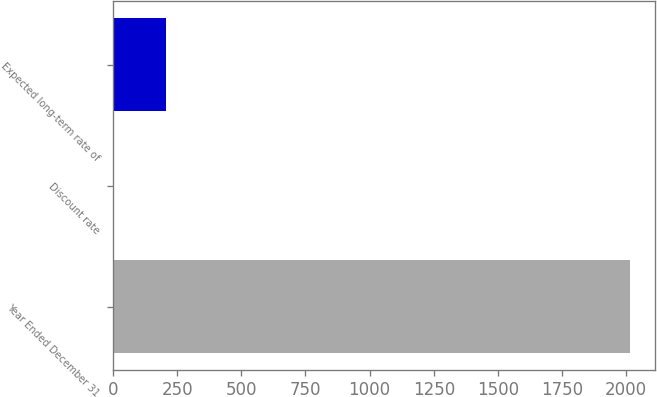Convert chart. <chart><loc_0><loc_0><loc_500><loc_500><bar_chart><fcel>Year Ended December 31<fcel>Discount rate<fcel>Expected long-term rate of<nl><fcel>2013<fcel>4<fcel>204.9<nl></chart> 